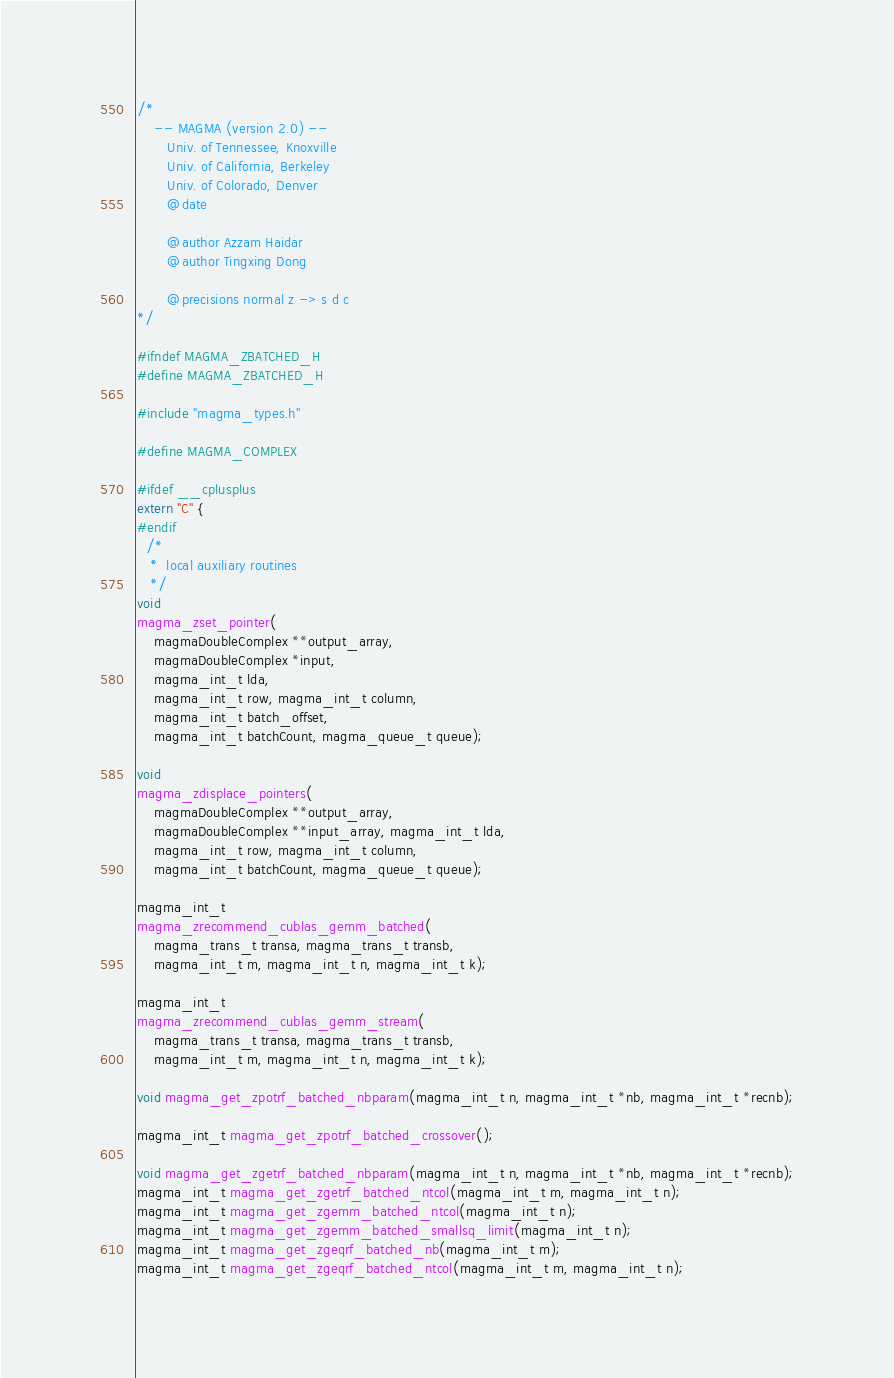Convert code to text. <code><loc_0><loc_0><loc_500><loc_500><_C_>/*
    -- MAGMA (version 2.0) --
       Univ. of Tennessee, Knoxville
       Univ. of California, Berkeley
       Univ. of Colorado, Denver
       @date

       @author Azzam Haidar
       @author Tingxing Dong

       @precisions normal z -> s d c
*/

#ifndef MAGMA_ZBATCHED_H
#define MAGMA_ZBATCHED_H

#include "magma_types.h"

#define MAGMA_COMPLEX

#ifdef __cplusplus
extern "C" {
#endif
  /*
   *  local auxiliary routines
   */
void
magma_zset_pointer(
    magmaDoubleComplex **output_array,
    magmaDoubleComplex *input,
    magma_int_t lda,
    magma_int_t row, magma_int_t column,
    magma_int_t batch_offset,
    magma_int_t batchCount, magma_queue_t queue);

void
magma_zdisplace_pointers(
    magmaDoubleComplex **output_array,
    magmaDoubleComplex **input_array, magma_int_t lda,
    magma_int_t row, magma_int_t column,
    magma_int_t batchCount, magma_queue_t queue);

magma_int_t
magma_zrecommend_cublas_gemm_batched(
    magma_trans_t transa, magma_trans_t transb,
    magma_int_t m, magma_int_t n, magma_int_t k);

magma_int_t
magma_zrecommend_cublas_gemm_stream(
    magma_trans_t transa, magma_trans_t transb,
    magma_int_t m, magma_int_t n, magma_int_t k);

void magma_get_zpotrf_batched_nbparam(magma_int_t n, magma_int_t *nb, magma_int_t *recnb);

magma_int_t magma_get_zpotrf_batched_crossover();

void magma_get_zgetrf_batched_nbparam(magma_int_t n, magma_int_t *nb, magma_int_t *recnb);
magma_int_t magma_get_zgetrf_batched_ntcol(magma_int_t m, magma_int_t n);
magma_int_t magma_get_zgemm_batched_ntcol(magma_int_t n);
magma_int_t magma_get_zgemm_batched_smallsq_limit(magma_int_t n);
magma_int_t magma_get_zgeqrf_batched_nb(magma_int_t m);
magma_int_t magma_get_zgeqrf_batched_ntcol(magma_int_t m, magma_int_t n);</code> 